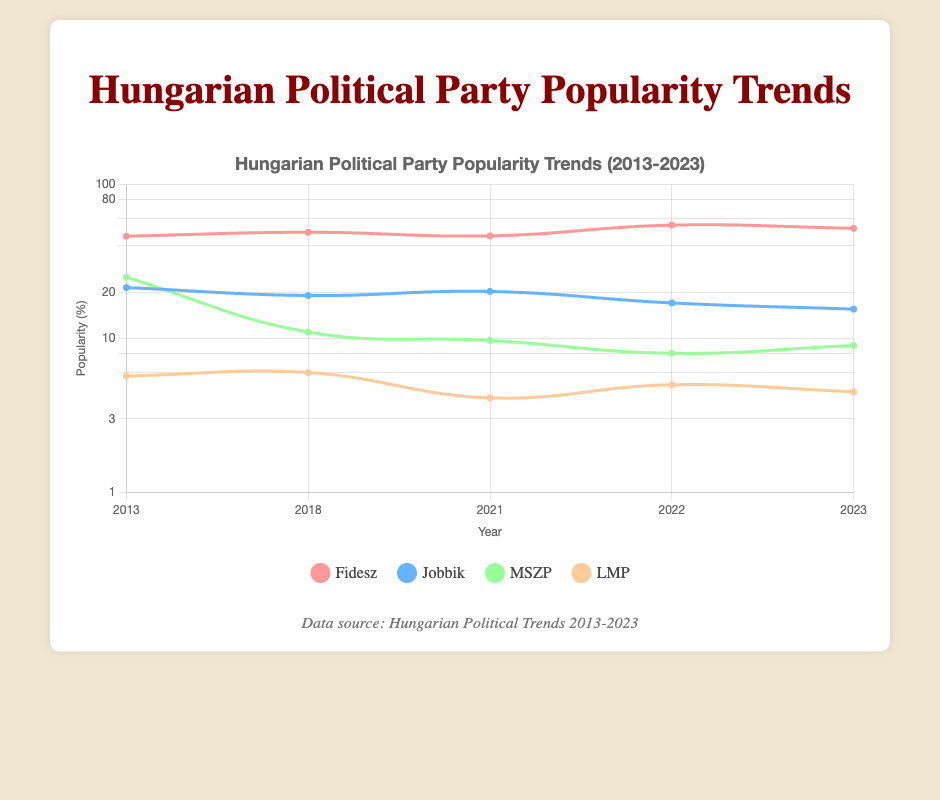What was the popularity of Fidesz in 2018? The table shows that in the year 2018, the popularity of Fidesz was recorded at 49.0%.
Answer: 49.0 In which year did Jobbik have its highest popularity? Looking at the data, Jobbik had the highest popularity in 2013 with a score of 21.4%.
Answer: 2013 Is it true that MSZP's popularity decreased from 2013 to 2023? To determine this, we can compare the popularity percentages from 2013 (25.0%) and 2023 (9.0%). Indeed, the popularity decreased over the years.
Answer: Yes What is the difference in popularity of Fidesz between 2022 and 2023? The popularity of Fidesz in 2022 was 54.5%, and in 2023, it was 52.0%. The difference can be calculated as 54.5 - 52.0 = 2.5.
Answer: 2.5 What is the average popularity of LMP from 2013 to 2023? We can find the relevant values: 5.7 (2013), 6.0 (2018), 4.1 (2021), 5.0 (2022), and 4.5 (2023). Summing these gives a total of 26.3, and since there are 5 data points, the average is 26.3 / 5 = 5.26.
Answer: 5.26 Which party consistently decreased in popularity from 2018 to 2023? Analyzing the respective years for each party, Jobbik had a descending trend, with popularity scores of 19.0 in 2018, 20.2 in 2021, and down to 15.5 in 2023.
Answer: Jobbik What was the total popularity of all parties in 2022? In 2022, the popularity scores are as follows: Fidesz 54.5, Jobbik 17.0, MSZP 8.0, and LMP 5.0. Adding these gives 54.5 + 17.0 + 8.0 + 5.0 = 84.5.
Answer: 84.5 Does MSZP's popularity show an upward trend over the years? Reviewing the years, MSZP's popularity has been 25.0 in 2013, 11.0 in 2018, 9.7 in 2021, 8.0 in 2022, and 9.0 in 2023. This indicates a downward trend overall.
Answer: No Which party had the lowest popularity in 2021? By comparing the popularity records from 2021, Fidesz had 46.4, Jobbik 20.2, MSZP 9.7, and LMP 4.1. LMP holds the lowest value in this year.
Answer: LMP 